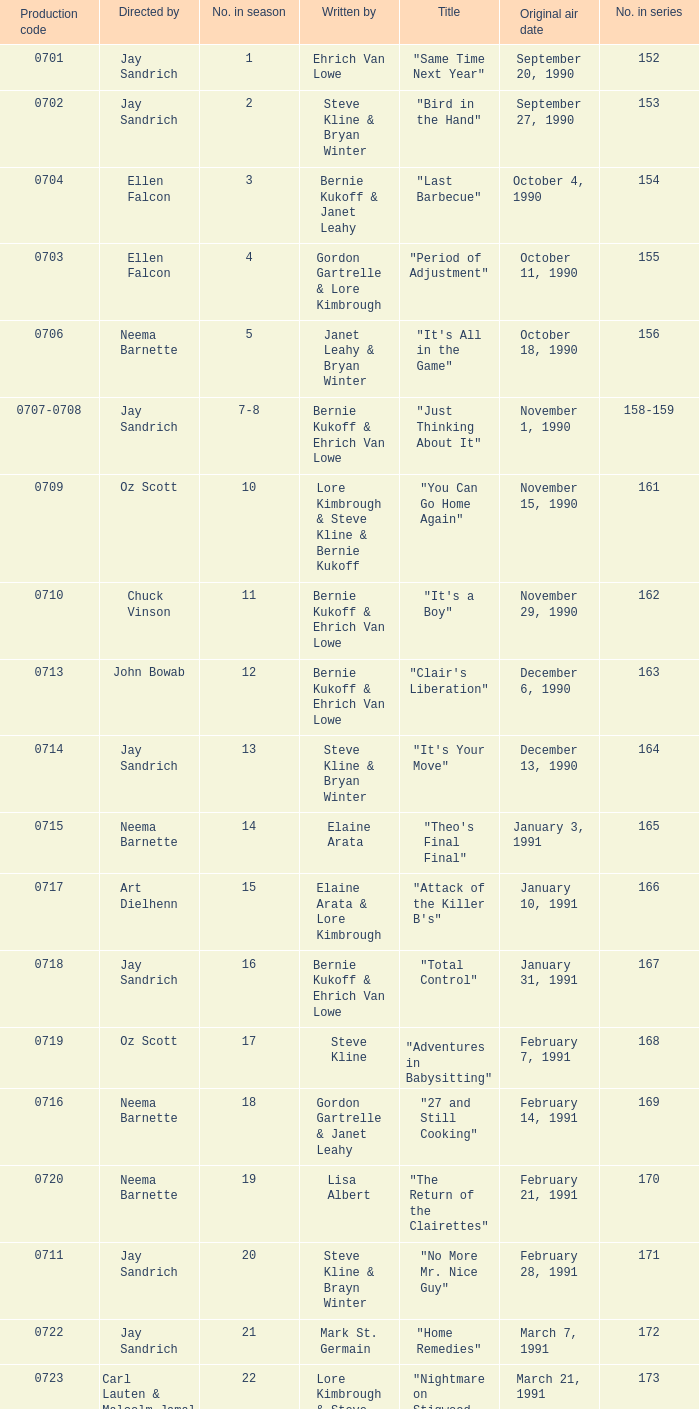The episode "adventures in babysitting" had what number in the season? 17.0. 